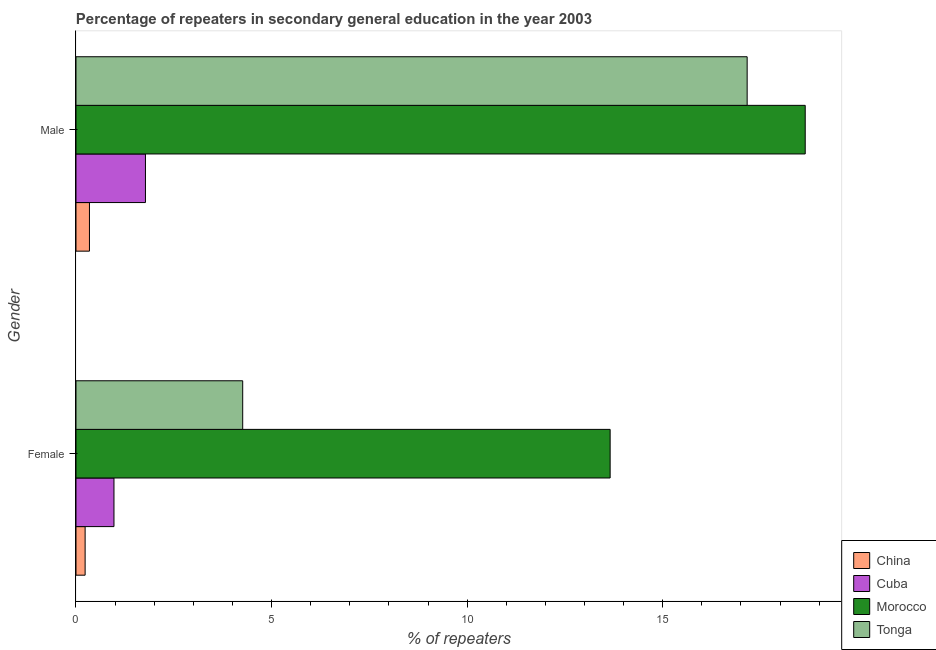Are the number of bars per tick equal to the number of legend labels?
Your answer should be compact. Yes. Are the number of bars on each tick of the Y-axis equal?
Keep it short and to the point. Yes. How many bars are there on the 2nd tick from the bottom?
Keep it short and to the point. 4. What is the label of the 1st group of bars from the top?
Ensure brevity in your answer.  Male. What is the percentage of female repeaters in Cuba?
Make the answer very short. 0.97. Across all countries, what is the maximum percentage of female repeaters?
Your answer should be very brief. 13.66. Across all countries, what is the minimum percentage of female repeaters?
Offer a terse response. 0.23. In which country was the percentage of male repeaters maximum?
Your answer should be very brief. Morocco. In which country was the percentage of male repeaters minimum?
Your answer should be very brief. China. What is the total percentage of female repeaters in the graph?
Your answer should be compact. 19.12. What is the difference between the percentage of female repeaters in China and that in Morocco?
Ensure brevity in your answer.  -13.42. What is the difference between the percentage of female repeaters in Tonga and the percentage of male repeaters in Cuba?
Your answer should be very brief. 2.49. What is the average percentage of male repeaters per country?
Your response must be concise. 9.48. What is the difference between the percentage of female repeaters and percentage of male repeaters in Tonga?
Keep it short and to the point. -12.9. What is the ratio of the percentage of female repeaters in Morocco to that in Tonga?
Provide a short and direct response. 3.2. In how many countries, is the percentage of male repeaters greater than the average percentage of male repeaters taken over all countries?
Your answer should be compact. 2. What does the 2nd bar from the top in Male represents?
Provide a short and direct response. Morocco. What does the 3rd bar from the bottom in Male represents?
Your answer should be very brief. Morocco. How many bars are there?
Keep it short and to the point. 8. Are the values on the major ticks of X-axis written in scientific E-notation?
Keep it short and to the point. No. Does the graph contain grids?
Your answer should be very brief. No. How many legend labels are there?
Offer a very short reply. 4. How are the legend labels stacked?
Ensure brevity in your answer.  Vertical. What is the title of the graph?
Your response must be concise. Percentage of repeaters in secondary general education in the year 2003. What is the label or title of the X-axis?
Ensure brevity in your answer.  % of repeaters. What is the % of repeaters in China in Female?
Your answer should be compact. 0.23. What is the % of repeaters of Cuba in Female?
Offer a very short reply. 0.97. What is the % of repeaters in Morocco in Female?
Offer a terse response. 13.66. What is the % of repeaters in Tonga in Female?
Keep it short and to the point. 4.26. What is the % of repeaters in China in Male?
Offer a very short reply. 0.34. What is the % of repeaters of Cuba in Male?
Provide a short and direct response. 1.78. What is the % of repeaters in Morocco in Male?
Your response must be concise. 18.64. What is the % of repeaters in Tonga in Male?
Offer a terse response. 17.16. Across all Gender, what is the maximum % of repeaters in China?
Offer a very short reply. 0.34. Across all Gender, what is the maximum % of repeaters in Cuba?
Your answer should be compact. 1.78. Across all Gender, what is the maximum % of repeaters of Morocco?
Offer a terse response. 18.64. Across all Gender, what is the maximum % of repeaters of Tonga?
Your answer should be compact. 17.16. Across all Gender, what is the minimum % of repeaters in China?
Offer a terse response. 0.23. Across all Gender, what is the minimum % of repeaters of Cuba?
Make the answer very short. 0.97. Across all Gender, what is the minimum % of repeaters of Morocco?
Offer a very short reply. 13.66. Across all Gender, what is the minimum % of repeaters in Tonga?
Make the answer very short. 4.26. What is the total % of repeaters in China in the graph?
Provide a succinct answer. 0.58. What is the total % of repeaters of Cuba in the graph?
Your answer should be very brief. 2.75. What is the total % of repeaters in Morocco in the graph?
Provide a succinct answer. 32.3. What is the total % of repeaters of Tonga in the graph?
Your response must be concise. 21.42. What is the difference between the % of repeaters of China in Female and that in Male?
Offer a very short reply. -0.11. What is the difference between the % of repeaters of Cuba in Female and that in Male?
Offer a terse response. -0.8. What is the difference between the % of repeaters of Morocco in Female and that in Male?
Offer a terse response. -4.99. What is the difference between the % of repeaters in Tonga in Female and that in Male?
Ensure brevity in your answer.  -12.9. What is the difference between the % of repeaters in China in Female and the % of repeaters in Cuba in Male?
Give a very brief answer. -1.54. What is the difference between the % of repeaters in China in Female and the % of repeaters in Morocco in Male?
Your answer should be very brief. -18.41. What is the difference between the % of repeaters of China in Female and the % of repeaters of Tonga in Male?
Provide a succinct answer. -16.93. What is the difference between the % of repeaters in Cuba in Female and the % of repeaters in Morocco in Male?
Your answer should be compact. -17.67. What is the difference between the % of repeaters in Cuba in Female and the % of repeaters in Tonga in Male?
Your response must be concise. -16.19. What is the difference between the % of repeaters of Morocco in Female and the % of repeaters of Tonga in Male?
Offer a very short reply. -3.5. What is the average % of repeaters of China per Gender?
Offer a very short reply. 0.29. What is the average % of repeaters of Cuba per Gender?
Provide a short and direct response. 1.37. What is the average % of repeaters in Morocco per Gender?
Your response must be concise. 16.15. What is the average % of repeaters of Tonga per Gender?
Your answer should be compact. 10.71. What is the difference between the % of repeaters in China and % of repeaters in Cuba in Female?
Offer a very short reply. -0.74. What is the difference between the % of repeaters in China and % of repeaters in Morocco in Female?
Provide a short and direct response. -13.42. What is the difference between the % of repeaters of China and % of repeaters of Tonga in Female?
Make the answer very short. -4.03. What is the difference between the % of repeaters of Cuba and % of repeaters of Morocco in Female?
Your answer should be very brief. -12.69. What is the difference between the % of repeaters in Cuba and % of repeaters in Tonga in Female?
Your answer should be compact. -3.29. What is the difference between the % of repeaters of Morocco and % of repeaters of Tonga in Female?
Your response must be concise. 9.39. What is the difference between the % of repeaters of China and % of repeaters of Cuba in Male?
Provide a short and direct response. -1.43. What is the difference between the % of repeaters of China and % of repeaters of Morocco in Male?
Give a very brief answer. -18.3. What is the difference between the % of repeaters in China and % of repeaters in Tonga in Male?
Offer a terse response. -16.82. What is the difference between the % of repeaters of Cuba and % of repeaters of Morocco in Male?
Your response must be concise. -16.87. What is the difference between the % of repeaters in Cuba and % of repeaters in Tonga in Male?
Your answer should be compact. -15.38. What is the difference between the % of repeaters of Morocco and % of repeaters of Tonga in Male?
Make the answer very short. 1.48. What is the ratio of the % of repeaters in China in Female to that in Male?
Your answer should be compact. 0.68. What is the ratio of the % of repeaters in Cuba in Female to that in Male?
Keep it short and to the point. 0.55. What is the ratio of the % of repeaters of Morocco in Female to that in Male?
Offer a very short reply. 0.73. What is the ratio of the % of repeaters in Tonga in Female to that in Male?
Ensure brevity in your answer.  0.25. What is the difference between the highest and the second highest % of repeaters of China?
Your answer should be compact. 0.11. What is the difference between the highest and the second highest % of repeaters in Cuba?
Offer a terse response. 0.8. What is the difference between the highest and the second highest % of repeaters of Morocco?
Offer a terse response. 4.99. What is the difference between the highest and the second highest % of repeaters in Tonga?
Offer a very short reply. 12.9. What is the difference between the highest and the lowest % of repeaters in China?
Your response must be concise. 0.11. What is the difference between the highest and the lowest % of repeaters in Cuba?
Ensure brevity in your answer.  0.8. What is the difference between the highest and the lowest % of repeaters of Morocco?
Offer a terse response. 4.99. What is the difference between the highest and the lowest % of repeaters in Tonga?
Offer a terse response. 12.9. 